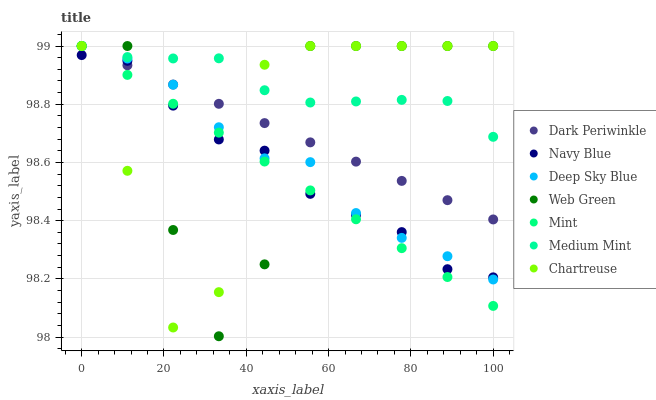Does Mint have the minimum area under the curve?
Answer yes or no. Yes. Does Medium Mint have the maximum area under the curve?
Answer yes or no. Yes. Does Navy Blue have the minimum area under the curve?
Answer yes or no. No. Does Navy Blue have the maximum area under the curve?
Answer yes or no. No. Is Dark Periwinkle the smoothest?
Answer yes or no. Yes. Is Web Green the roughest?
Answer yes or no. Yes. Is Navy Blue the smoothest?
Answer yes or no. No. Is Navy Blue the roughest?
Answer yes or no. No. Does Web Green have the lowest value?
Answer yes or no. Yes. Does Navy Blue have the lowest value?
Answer yes or no. No. Does Dark Periwinkle have the highest value?
Answer yes or no. Yes. Does Navy Blue have the highest value?
Answer yes or no. No. Is Navy Blue less than Medium Mint?
Answer yes or no. Yes. Is Medium Mint greater than Navy Blue?
Answer yes or no. Yes. Does Chartreuse intersect Deep Sky Blue?
Answer yes or no. Yes. Is Chartreuse less than Deep Sky Blue?
Answer yes or no. No. Is Chartreuse greater than Deep Sky Blue?
Answer yes or no. No. Does Navy Blue intersect Medium Mint?
Answer yes or no. No. 